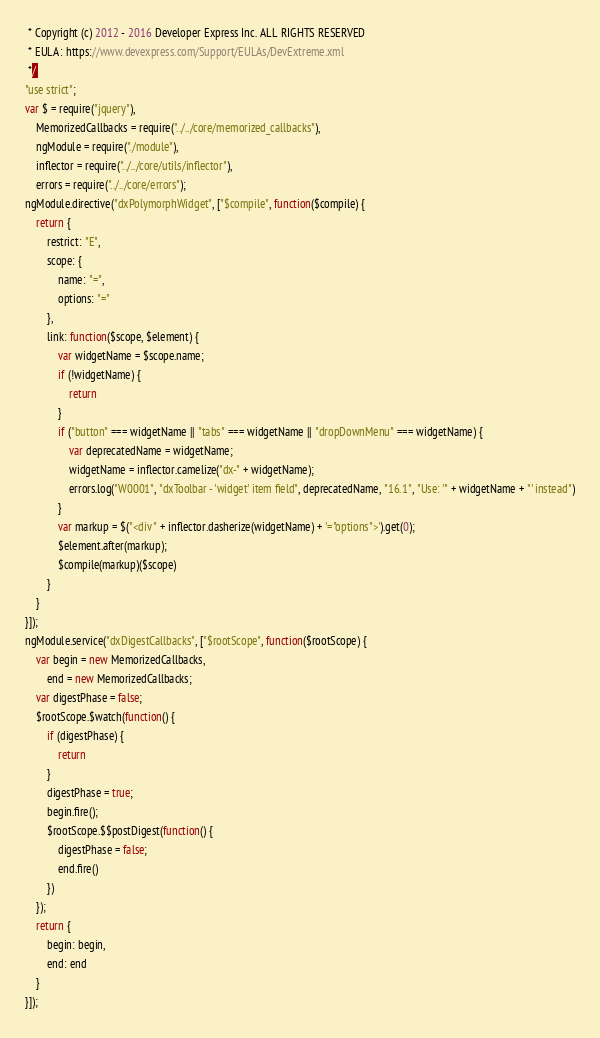Convert code to text. <code><loc_0><loc_0><loc_500><loc_500><_JavaScript_> * Copyright (c) 2012 - 2016 Developer Express Inc. ALL RIGHTS RESERVED
 * EULA: https://www.devexpress.com/Support/EULAs/DevExtreme.xml
 */
"use strict";
var $ = require("jquery"),
    MemorizedCallbacks = require("../../core/memorized_callbacks"),
    ngModule = require("./module"),
    inflector = require("../../core/utils/inflector"),
    errors = require("../../core/errors");
ngModule.directive("dxPolymorphWidget", ["$compile", function($compile) {
    return {
        restrict: "E",
        scope: {
            name: "=",
            options: "="
        },
        link: function($scope, $element) {
            var widgetName = $scope.name;
            if (!widgetName) {
                return
            }
            if ("button" === widgetName || "tabs" === widgetName || "dropDownMenu" === widgetName) {
                var deprecatedName = widgetName;
                widgetName = inflector.camelize("dx-" + widgetName);
                errors.log("W0001", "dxToolbar - 'widget' item field", deprecatedName, "16.1", "Use: '" + widgetName + "' instead")
            }
            var markup = $("<div " + inflector.dasherize(widgetName) + '="options">').get(0);
            $element.after(markup);
            $compile(markup)($scope)
        }
    }
}]);
ngModule.service("dxDigestCallbacks", ["$rootScope", function($rootScope) {
    var begin = new MemorizedCallbacks,
        end = new MemorizedCallbacks;
    var digestPhase = false;
    $rootScope.$watch(function() {
        if (digestPhase) {
            return
        }
        digestPhase = true;
        begin.fire();
        $rootScope.$$postDigest(function() {
            digestPhase = false;
            end.fire()
        })
    });
    return {
        begin: begin,
        end: end
    }
}]);
</code> 